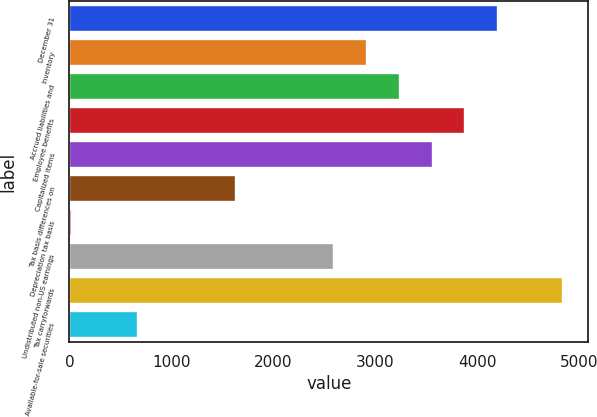Convert chart. <chart><loc_0><loc_0><loc_500><loc_500><bar_chart><fcel>December 31<fcel>Inventory<fcel>Accrued liabilities and<fcel>Employee benefits<fcel>Capitalized items<fcel>Tax basis differences on<fcel>Depreciation tax basis<fcel>Undistributed non-US earnings<fcel>Tax carryforwards<fcel>Available-for-sale securities<nl><fcel>4203.3<fcel>2918.9<fcel>3240<fcel>3882.2<fcel>3561.1<fcel>1634.5<fcel>29<fcel>2597.8<fcel>4845.5<fcel>671.2<nl></chart> 